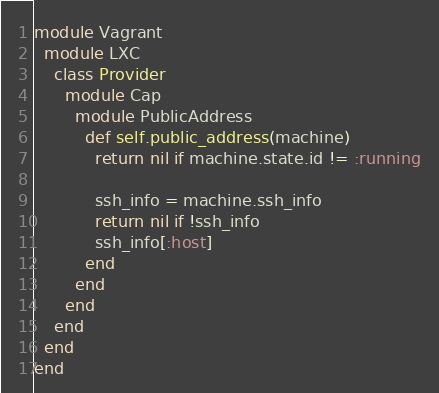Convert code to text. <code><loc_0><loc_0><loc_500><loc_500><_Ruby_>module Vagrant
  module LXC
    class Provider
      module Cap
        module PublicAddress
          def self.public_address(machine)
            return nil if machine.state.id != :running

            ssh_info = machine.ssh_info
            return nil if !ssh_info
            ssh_info[:host]
          end
        end
      end
    end
  end
end
</code> 